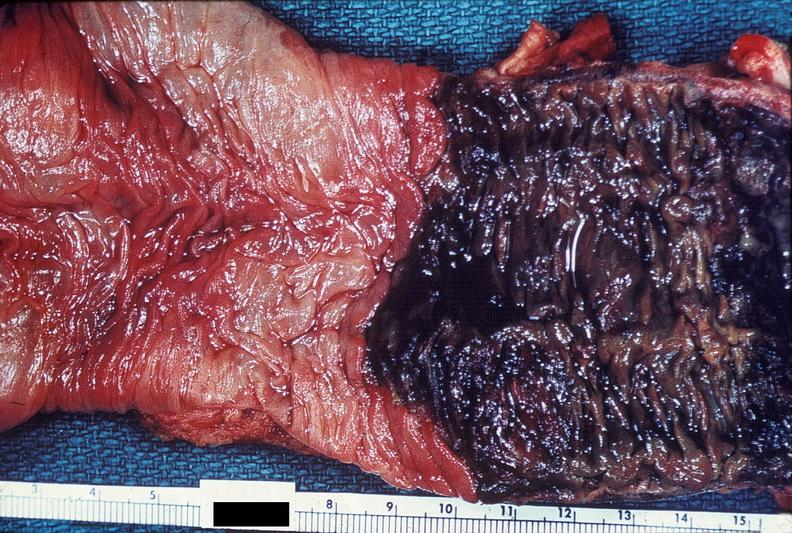what does this image show?
Answer the question using a single word or phrase. Colon 